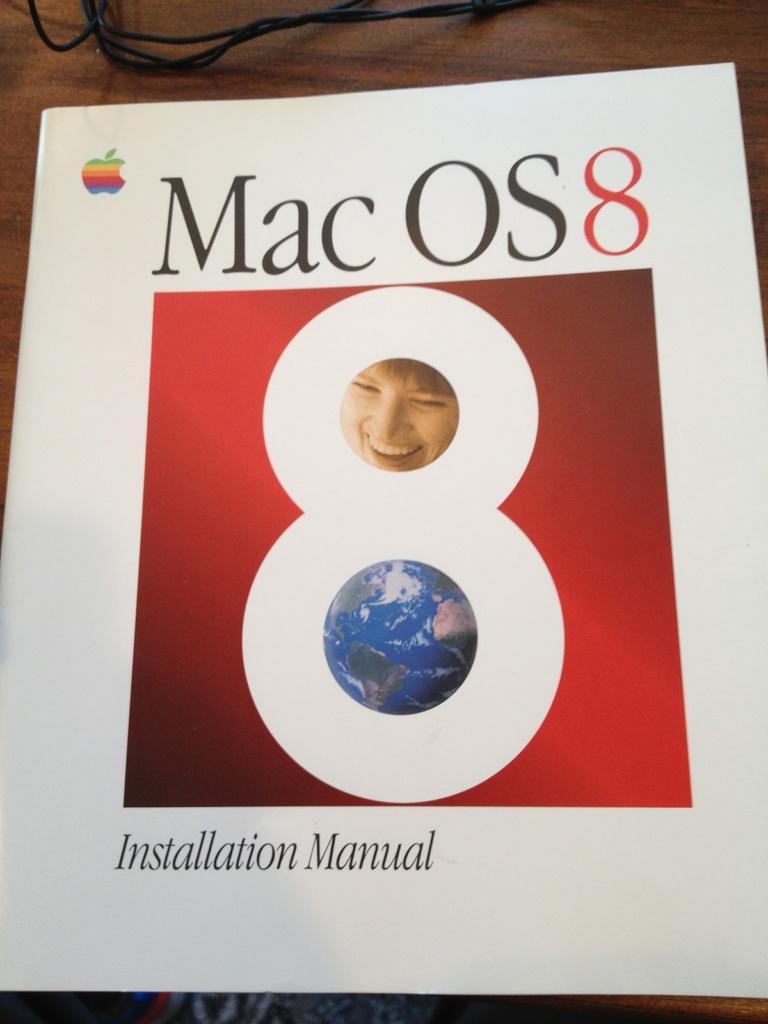Describe this image in one or two sentences. In this image we can see a book. We can see a globe, a face of a person and some text printed on the cover page of the book. There are few cables at the top of the image. We can see a wooden object in the image. 